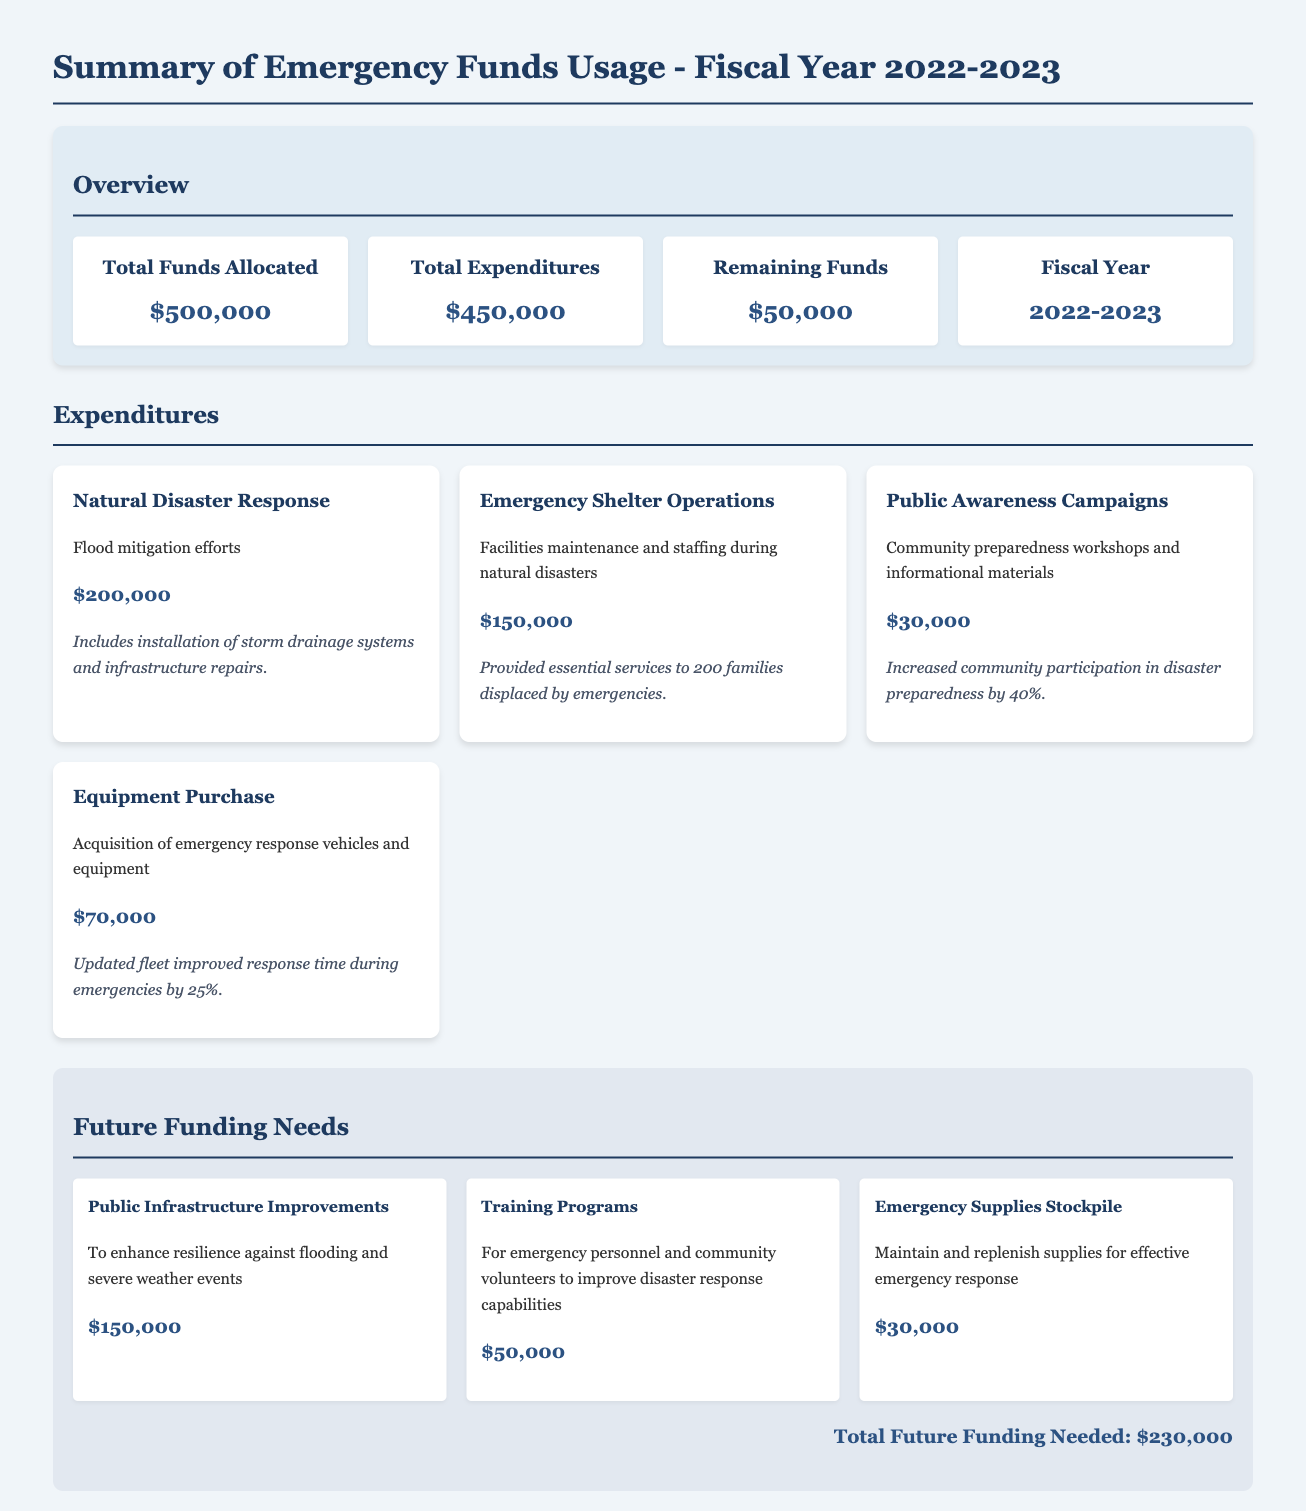What is the total funds allocated? The total funds allocated is specified in the overview section of the document, which lists $500,000.
Answer: $500,000 What is the total expenditures? The total expenditures can be found in the overview section, which details the amount as $450,000.
Answer: $450,000 What is the remaining funds? The remaining funds are shown in the overview section, indicating an amount of $50,000.
Answer: $50,000 How much was spent on natural disaster response? The expenditure item for natural disaster response indicates a spending amount of $200,000.
Answer: $200,000 What percentage increase in community participation was achieved through public awareness campaigns? The document states that community participation increased by 40% due to these campaigns.
Answer: 40% What is one of the future funding needs? The future funding needs include public infrastructure improvements as listed in the document.
Answer: Public Infrastructure Improvements How much is needed for emergency supplies stockpile? The amount required for maintaining and replenishing emergency supplies stockpile is noted as $30,000.
Answer: $30,000 What was the total future funding needed? The document summarizes the total future funding needed as the sum of various future needs, totaling $230,000.
Answer: $230,000 